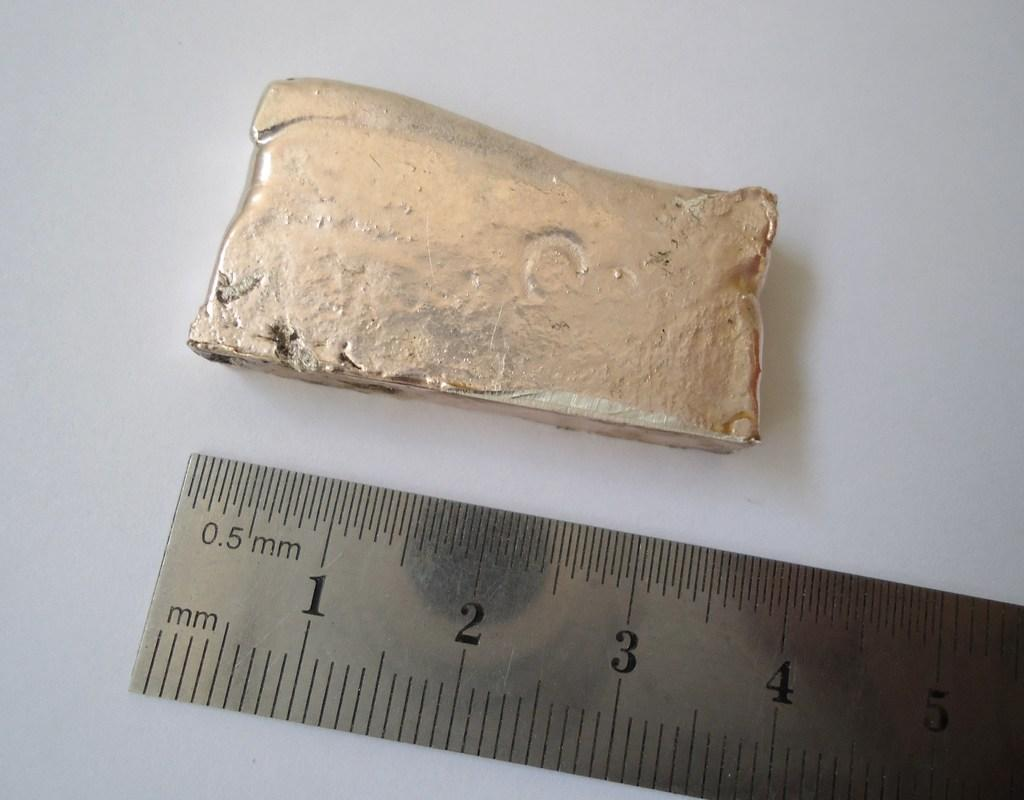<image>
Render a clear and concise summary of the photo. An old gold bar that is roughly four inches long 